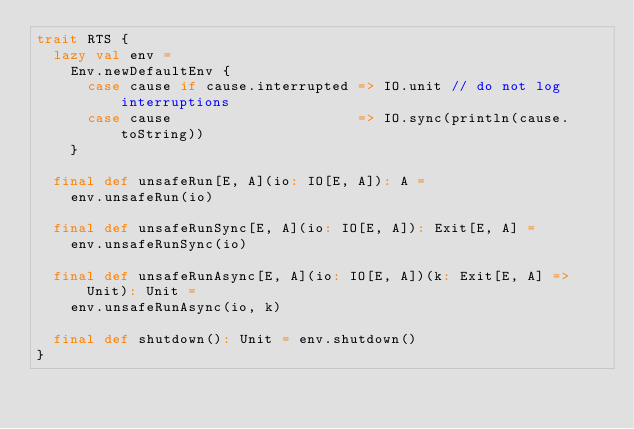<code> <loc_0><loc_0><loc_500><loc_500><_Scala_>trait RTS {
  lazy val env =
    Env.newDefaultEnv {
      case cause if cause.interrupted => IO.unit // do not log interruptions
      case cause                      => IO.sync(println(cause.toString))
    }

  final def unsafeRun[E, A](io: IO[E, A]): A =
    env.unsafeRun(io)

  final def unsafeRunSync[E, A](io: IO[E, A]): Exit[E, A] =
    env.unsafeRunSync(io)

  final def unsafeRunAsync[E, A](io: IO[E, A])(k: Exit[E, A] => Unit): Unit =
    env.unsafeRunAsync(io, k)

  final def shutdown(): Unit = env.shutdown()
}
</code> 